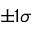<formula> <loc_0><loc_0><loc_500><loc_500>\pm 1 \sigma</formula> 